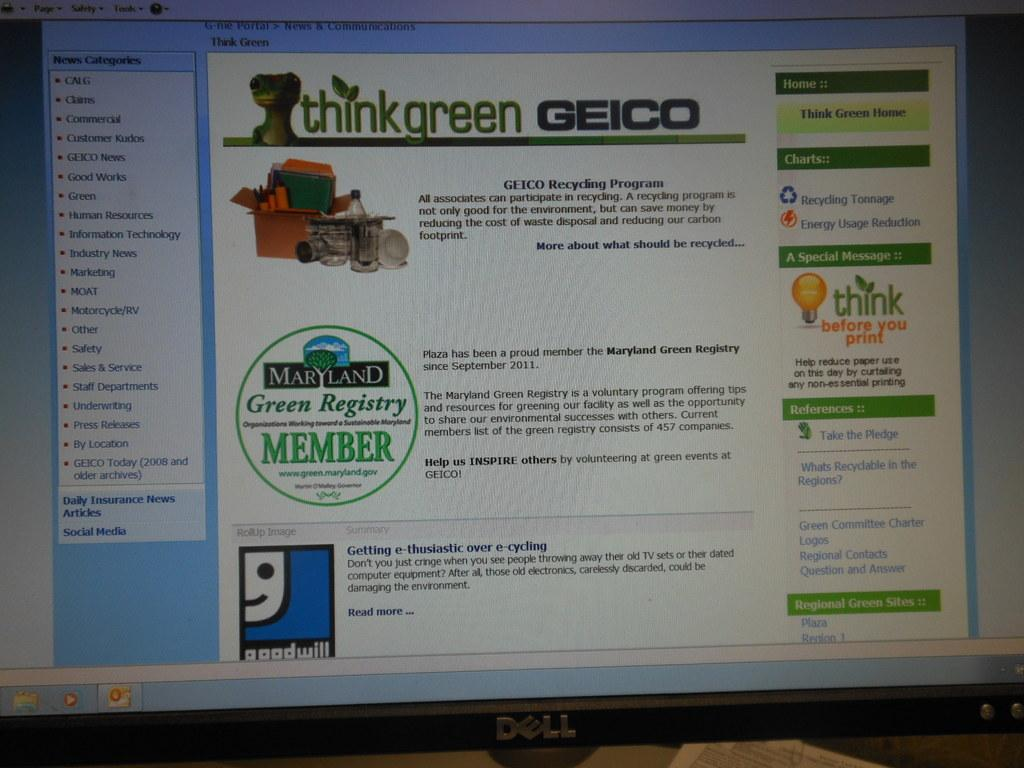<image>
Provide a brief description of the given image. Dell computer screen with a webpage about geico 